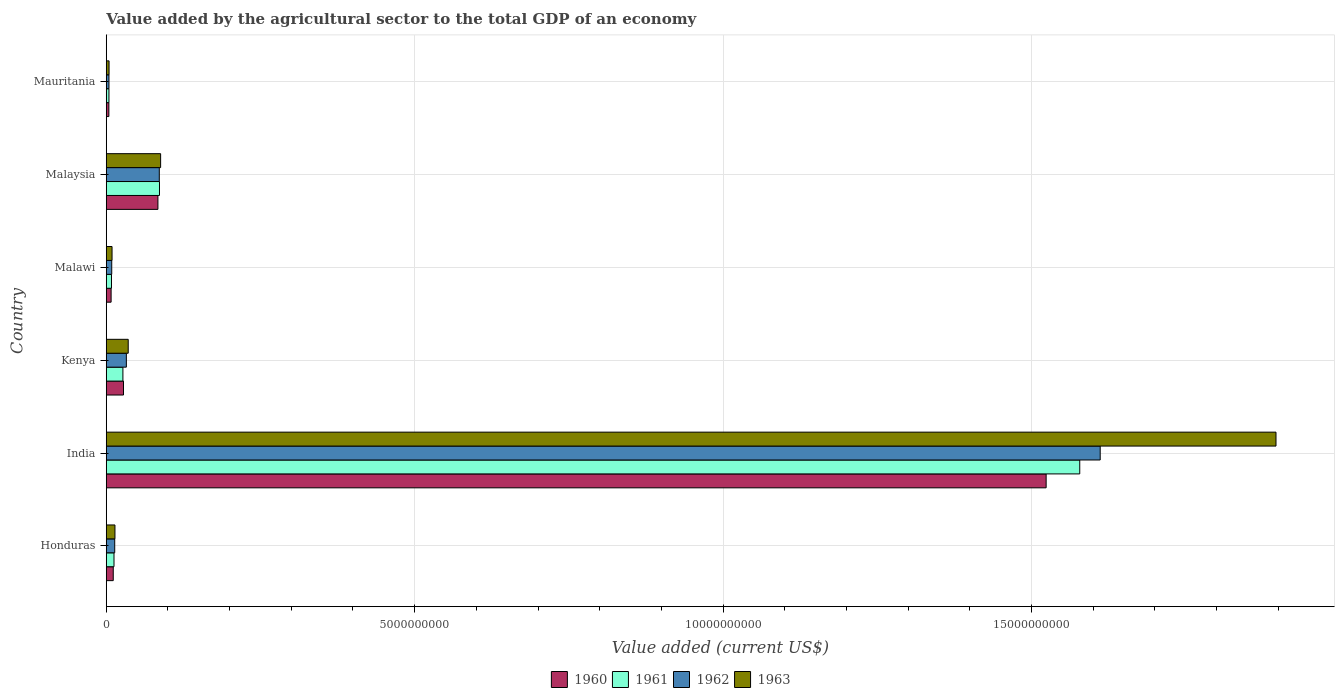How many groups of bars are there?
Your response must be concise. 6. How many bars are there on the 1st tick from the bottom?
Your response must be concise. 4. What is the label of the 5th group of bars from the top?
Your answer should be compact. India. In how many cases, is the number of bars for a given country not equal to the number of legend labels?
Your answer should be compact. 0. What is the value added by the agricultural sector to the total GDP in 1961 in Malaysia?
Your answer should be compact. 8.63e+08. Across all countries, what is the maximum value added by the agricultural sector to the total GDP in 1963?
Keep it short and to the point. 1.90e+1. Across all countries, what is the minimum value added by the agricultural sector to the total GDP in 1963?
Keep it short and to the point. 4.57e+07. In which country was the value added by the agricultural sector to the total GDP in 1962 minimum?
Your answer should be very brief. Mauritania. What is the total value added by the agricultural sector to the total GDP in 1961 in the graph?
Offer a terse response. 1.72e+1. What is the difference between the value added by the agricultural sector to the total GDP in 1960 in India and that in Malaysia?
Your answer should be very brief. 1.44e+1. What is the difference between the value added by the agricultural sector to the total GDP in 1963 in India and the value added by the agricultural sector to the total GDP in 1961 in Malawi?
Provide a succinct answer. 1.89e+1. What is the average value added by the agricultural sector to the total GDP in 1962 per country?
Keep it short and to the point. 2.93e+09. What is the difference between the value added by the agricultural sector to the total GDP in 1962 and value added by the agricultural sector to the total GDP in 1961 in Malawi?
Your answer should be compact. 4.20e+06. In how many countries, is the value added by the agricultural sector to the total GDP in 1960 greater than 2000000000 US$?
Offer a terse response. 1. What is the ratio of the value added by the agricultural sector to the total GDP in 1961 in Honduras to that in India?
Offer a very short reply. 0.01. Is the difference between the value added by the agricultural sector to the total GDP in 1962 in Malaysia and Mauritania greater than the difference between the value added by the agricultural sector to the total GDP in 1961 in Malaysia and Mauritania?
Offer a very short reply. No. What is the difference between the highest and the second highest value added by the agricultural sector to the total GDP in 1961?
Your answer should be compact. 1.49e+1. What is the difference between the highest and the lowest value added by the agricultural sector to the total GDP in 1962?
Provide a short and direct response. 1.61e+1. Is it the case that in every country, the sum of the value added by the agricultural sector to the total GDP in 1962 and value added by the agricultural sector to the total GDP in 1960 is greater than the sum of value added by the agricultural sector to the total GDP in 1961 and value added by the agricultural sector to the total GDP in 1963?
Offer a terse response. No. What does the 2nd bar from the top in Honduras represents?
Offer a terse response. 1962. How many bars are there?
Provide a short and direct response. 24. What is the difference between two consecutive major ticks on the X-axis?
Give a very brief answer. 5.00e+09. Are the values on the major ticks of X-axis written in scientific E-notation?
Provide a succinct answer. No. Does the graph contain any zero values?
Offer a very short reply. No. How many legend labels are there?
Ensure brevity in your answer.  4. What is the title of the graph?
Give a very brief answer. Value added by the agricultural sector to the total GDP of an economy. Does "2006" appear as one of the legend labels in the graph?
Offer a very short reply. No. What is the label or title of the X-axis?
Offer a very short reply. Value added (current US$). What is the Value added (current US$) in 1960 in Honduras?
Offer a very short reply. 1.14e+08. What is the Value added (current US$) of 1961 in Honduras?
Ensure brevity in your answer.  1.26e+08. What is the Value added (current US$) in 1962 in Honduras?
Your answer should be very brief. 1.37e+08. What is the Value added (current US$) in 1963 in Honduras?
Offer a terse response. 1.41e+08. What is the Value added (current US$) of 1960 in India?
Give a very brief answer. 1.52e+1. What is the Value added (current US$) of 1961 in India?
Offer a very short reply. 1.58e+1. What is the Value added (current US$) of 1962 in India?
Provide a short and direct response. 1.61e+1. What is the Value added (current US$) of 1963 in India?
Keep it short and to the point. 1.90e+1. What is the Value added (current US$) of 1960 in Kenya?
Your answer should be very brief. 2.80e+08. What is the Value added (current US$) in 1961 in Kenya?
Ensure brevity in your answer.  2.70e+08. What is the Value added (current US$) of 1962 in Kenya?
Give a very brief answer. 3.26e+08. What is the Value added (current US$) in 1963 in Kenya?
Ensure brevity in your answer.  3.56e+08. What is the Value added (current US$) in 1960 in Malawi?
Provide a short and direct response. 7.88e+07. What is the Value added (current US$) of 1961 in Malawi?
Your answer should be very brief. 8.48e+07. What is the Value added (current US$) in 1962 in Malawi?
Make the answer very short. 8.90e+07. What is the Value added (current US$) in 1963 in Malawi?
Your answer should be very brief. 9.39e+07. What is the Value added (current US$) in 1960 in Malaysia?
Offer a terse response. 8.38e+08. What is the Value added (current US$) in 1961 in Malaysia?
Ensure brevity in your answer.  8.63e+08. What is the Value added (current US$) in 1962 in Malaysia?
Make the answer very short. 8.60e+08. What is the Value added (current US$) of 1963 in Malaysia?
Ensure brevity in your answer.  8.82e+08. What is the Value added (current US$) in 1960 in Mauritania?
Give a very brief answer. 4.26e+07. What is the Value added (current US$) in 1961 in Mauritania?
Your answer should be compact. 4.37e+07. What is the Value added (current US$) in 1962 in Mauritania?
Provide a short and direct response. 4.41e+07. What is the Value added (current US$) of 1963 in Mauritania?
Your response must be concise. 4.57e+07. Across all countries, what is the maximum Value added (current US$) in 1960?
Give a very brief answer. 1.52e+1. Across all countries, what is the maximum Value added (current US$) of 1961?
Offer a very short reply. 1.58e+1. Across all countries, what is the maximum Value added (current US$) in 1962?
Your answer should be very brief. 1.61e+1. Across all countries, what is the maximum Value added (current US$) of 1963?
Provide a short and direct response. 1.90e+1. Across all countries, what is the minimum Value added (current US$) of 1960?
Give a very brief answer. 4.26e+07. Across all countries, what is the minimum Value added (current US$) in 1961?
Give a very brief answer. 4.37e+07. Across all countries, what is the minimum Value added (current US$) of 1962?
Ensure brevity in your answer.  4.41e+07. Across all countries, what is the minimum Value added (current US$) in 1963?
Offer a very short reply. 4.57e+07. What is the total Value added (current US$) of 1960 in the graph?
Give a very brief answer. 1.66e+1. What is the total Value added (current US$) of 1961 in the graph?
Ensure brevity in your answer.  1.72e+1. What is the total Value added (current US$) of 1962 in the graph?
Offer a very short reply. 1.76e+1. What is the total Value added (current US$) in 1963 in the graph?
Provide a succinct answer. 2.05e+1. What is the difference between the Value added (current US$) in 1960 in Honduras and that in India?
Give a very brief answer. -1.51e+1. What is the difference between the Value added (current US$) of 1961 in Honduras and that in India?
Ensure brevity in your answer.  -1.57e+1. What is the difference between the Value added (current US$) of 1962 in Honduras and that in India?
Your answer should be compact. -1.60e+1. What is the difference between the Value added (current US$) in 1963 in Honduras and that in India?
Ensure brevity in your answer.  -1.88e+1. What is the difference between the Value added (current US$) of 1960 in Honduras and that in Kenya?
Your response must be concise. -1.66e+08. What is the difference between the Value added (current US$) in 1961 in Honduras and that in Kenya?
Offer a terse response. -1.45e+08. What is the difference between the Value added (current US$) in 1962 in Honduras and that in Kenya?
Your response must be concise. -1.89e+08. What is the difference between the Value added (current US$) of 1963 in Honduras and that in Kenya?
Your answer should be very brief. -2.15e+08. What is the difference between the Value added (current US$) in 1960 in Honduras and that in Malawi?
Keep it short and to the point. 3.47e+07. What is the difference between the Value added (current US$) of 1961 in Honduras and that in Malawi?
Make the answer very short. 4.08e+07. What is the difference between the Value added (current US$) in 1962 in Honduras and that in Malawi?
Ensure brevity in your answer.  4.82e+07. What is the difference between the Value added (current US$) of 1963 in Honduras and that in Malawi?
Your answer should be compact. 4.72e+07. What is the difference between the Value added (current US$) of 1960 in Honduras and that in Malaysia?
Give a very brief answer. -7.24e+08. What is the difference between the Value added (current US$) in 1961 in Honduras and that in Malaysia?
Offer a very short reply. -7.37e+08. What is the difference between the Value added (current US$) of 1962 in Honduras and that in Malaysia?
Give a very brief answer. -7.23e+08. What is the difference between the Value added (current US$) of 1963 in Honduras and that in Malaysia?
Your response must be concise. -7.40e+08. What is the difference between the Value added (current US$) of 1960 in Honduras and that in Mauritania?
Your answer should be very brief. 7.09e+07. What is the difference between the Value added (current US$) of 1961 in Honduras and that in Mauritania?
Your response must be concise. 8.19e+07. What is the difference between the Value added (current US$) of 1962 in Honduras and that in Mauritania?
Ensure brevity in your answer.  9.31e+07. What is the difference between the Value added (current US$) in 1963 in Honduras and that in Mauritania?
Offer a terse response. 9.55e+07. What is the difference between the Value added (current US$) of 1960 in India and that in Kenya?
Provide a short and direct response. 1.50e+1. What is the difference between the Value added (current US$) of 1961 in India and that in Kenya?
Your answer should be compact. 1.55e+1. What is the difference between the Value added (current US$) in 1962 in India and that in Kenya?
Provide a succinct answer. 1.58e+1. What is the difference between the Value added (current US$) in 1963 in India and that in Kenya?
Provide a short and direct response. 1.86e+1. What is the difference between the Value added (current US$) in 1960 in India and that in Malawi?
Provide a succinct answer. 1.52e+1. What is the difference between the Value added (current US$) of 1961 in India and that in Malawi?
Offer a terse response. 1.57e+1. What is the difference between the Value added (current US$) in 1962 in India and that in Malawi?
Offer a very short reply. 1.60e+1. What is the difference between the Value added (current US$) of 1963 in India and that in Malawi?
Your answer should be very brief. 1.89e+1. What is the difference between the Value added (current US$) in 1960 in India and that in Malaysia?
Ensure brevity in your answer.  1.44e+1. What is the difference between the Value added (current US$) in 1961 in India and that in Malaysia?
Keep it short and to the point. 1.49e+1. What is the difference between the Value added (current US$) in 1962 in India and that in Malaysia?
Your response must be concise. 1.53e+1. What is the difference between the Value added (current US$) of 1963 in India and that in Malaysia?
Your response must be concise. 1.81e+1. What is the difference between the Value added (current US$) of 1960 in India and that in Mauritania?
Your answer should be compact. 1.52e+1. What is the difference between the Value added (current US$) of 1961 in India and that in Mauritania?
Offer a very short reply. 1.57e+1. What is the difference between the Value added (current US$) in 1962 in India and that in Mauritania?
Provide a succinct answer. 1.61e+1. What is the difference between the Value added (current US$) of 1963 in India and that in Mauritania?
Keep it short and to the point. 1.89e+1. What is the difference between the Value added (current US$) in 1960 in Kenya and that in Malawi?
Your answer should be very brief. 2.01e+08. What is the difference between the Value added (current US$) of 1961 in Kenya and that in Malawi?
Your answer should be compact. 1.85e+08. What is the difference between the Value added (current US$) in 1962 in Kenya and that in Malawi?
Keep it short and to the point. 2.37e+08. What is the difference between the Value added (current US$) of 1963 in Kenya and that in Malawi?
Your response must be concise. 2.62e+08. What is the difference between the Value added (current US$) of 1960 in Kenya and that in Malaysia?
Your answer should be compact. -5.58e+08. What is the difference between the Value added (current US$) of 1961 in Kenya and that in Malaysia?
Give a very brief answer. -5.93e+08. What is the difference between the Value added (current US$) of 1962 in Kenya and that in Malaysia?
Give a very brief answer. -5.34e+08. What is the difference between the Value added (current US$) in 1963 in Kenya and that in Malaysia?
Ensure brevity in your answer.  -5.25e+08. What is the difference between the Value added (current US$) of 1960 in Kenya and that in Mauritania?
Offer a very short reply. 2.37e+08. What is the difference between the Value added (current US$) in 1961 in Kenya and that in Mauritania?
Your answer should be very brief. 2.26e+08. What is the difference between the Value added (current US$) of 1962 in Kenya and that in Mauritania?
Offer a very short reply. 2.82e+08. What is the difference between the Value added (current US$) in 1963 in Kenya and that in Mauritania?
Give a very brief answer. 3.11e+08. What is the difference between the Value added (current US$) of 1960 in Malawi and that in Malaysia?
Provide a succinct answer. -7.59e+08. What is the difference between the Value added (current US$) of 1961 in Malawi and that in Malaysia?
Offer a terse response. -7.78e+08. What is the difference between the Value added (current US$) of 1962 in Malawi and that in Malaysia?
Provide a succinct answer. -7.71e+08. What is the difference between the Value added (current US$) of 1963 in Malawi and that in Malaysia?
Ensure brevity in your answer.  -7.88e+08. What is the difference between the Value added (current US$) in 1960 in Malawi and that in Mauritania?
Keep it short and to the point. 3.62e+07. What is the difference between the Value added (current US$) of 1961 in Malawi and that in Mauritania?
Offer a terse response. 4.11e+07. What is the difference between the Value added (current US$) in 1962 in Malawi and that in Mauritania?
Give a very brief answer. 4.49e+07. What is the difference between the Value added (current US$) of 1963 in Malawi and that in Mauritania?
Provide a short and direct response. 4.83e+07. What is the difference between the Value added (current US$) in 1960 in Malaysia and that in Mauritania?
Provide a succinct answer. 7.95e+08. What is the difference between the Value added (current US$) in 1961 in Malaysia and that in Mauritania?
Offer a terse response. 8.19e+08. What is the difference between the Value added (current US$) of 1962 in Malaysia and that in Mauritania?
Keep it short and to the point. 8.16e+08. What is the difference between the Value added (current US$) in 1963 in Malaysia and that in Mauritania?
Your response must be concise. 8.36e+08. What is the difference between the Value added (current US$) in 1960 in Honduras and the Value added (current US$) in 1961 in India?
Your response must be concise. -1.57e+1. What is the difference between the Value added (current US$) of 1960 in Honduras and the Value added (current US$) of 1962 in India?
Ensure brevity in your answer.  -1.60e+1. What is the difference between the Value added (current US$) in 1960 in Honduras and the Value added (current US$) in 1963 in India?
Make the answer very short. -1.89e+1. What is the difference between the Value added (current US$) in 1961 in Honduras and the Value added (current US$) in 1962 in India?
Your answer should be very brief. -1.60e+1. What is the difference between the Value added (current US$) in 1961 in Honduras and the Value added (current US$) in 1963 in India?
Offer a terse response. -1.88e+1. What is the difference between the Value added (current US$) of 1962 in Honduras and the Value added (current US$) of 1963 in India?
Keep it short and to the point. -1.88e+1. What is the difference between the Value added (current US$) in 1960 in Honduras and the Value added (current US$) in 1961 in Kenya?
Offer a very short reply. -1.57e+08. What is the difference between the Value added (current US$) of 1960 in Honduras and the Value added (current US$) of 1962 in Kenya?
Provide a short and direct response. -2.13e+08. What is the difference between the Value added (current US$) of 1960 in Honduras and the Value added (current US$) of 1963 in Kenya?
Give a very brief answer. -2.43e+08. What is the difference between the Value added (current US$) in 1961 in Honduras and the Value added (current US$) in 1962 in Kenya?
Your response must be concise. -2.01e+08. What is the difference between the Value added (current US$) in 1961 in Honduras and the Value added (current US$) in 1963 in Kenya?
Provide a succinct answer. -2.31e+08. What is the difference between the Value added (current US$) of 1962 in Honduras and the Value added (current US$) of 1963 in Kenya?
Give a very brief answer. -2.19e+08. What is the difference between the Value added (current US$) in 1960 in Honduras and the Value added (current US$) in 1961 in Malawi?
Offer a very short reply. 2.87e+07. What is the difference between the Value added (current US$) of 1960 in Honduras and the Value added (current US$) of 1962 in Malawi?
Keep it short and to the point. 2.45e+07. What is the difference between the Value added (current US$) of 1960 in Honduras and the Value added (current US$) of 1963 in Malawi?
Provide a succinct answer. 1.96e+07. What is the difference between the Value added (current US$) in 1961 in Honduras and the Value added (current US$) in 1962 in Malawi?
Your answer should be compact. 3.66e+07. What is the difference between the Value added (current US$) in 1961 in Honduras and the Value added (current US$) in 1963 in Malawi?
Offer a terse response. 3.17e+07. What is the difference between the Value added (current US$) of 1962 in Honduras and the Value added (current US$) of 1963 in Malawi?
Offer a very short reply. 4.33e+07. What is the difference between the Value added (current US$) in 1960 in Honduras and the Value added (current US$) in 1961 in Malaysia?
Keep it short and to the point. -7.50e+08. What is the difference between the Value added (current US$) in 1960 in Honduras and the Value added (current US$) in 1962 in Malaysia?
Ensure brevity in your answer.  -7.47e+08. What is the difference between the Value added (current US$) in 1960 in Honduras and the Value added (current US$) in 1963 in Malaysia?
Keep it short and to the point. -7.68e+08. What is the difference between the Value added (current US$) of 1961 in Honduras and the Value added (current US$) of 1962 in Malaysia?
Ensure brevity in your answer.  -7.34e+08. What is the difference between the Value added (current US$) of 1961 in Honduras and the Value added (current US$) of 1963 in Malaysia?
Provide a short and direct response. -7.56e+08. What is the difference between the Value added (current US$) in 1962 in Honduras and the Value added (current US$) in 1963 in Malaysia?
Ensure brevity in your answer.  -7.44e+08. What is the difference between the Value added (current US$) in 1960 in Honduras and the Value added (current US$) in 1961 in Mauritania?
Provide a succinct answer. 6.98e+07. What is the difference between the Value added (current US$) of 1960 in Honduras and the Value added (current US$) of 1962 in Mauritania?
Your answer should be very brief. 6.94e+07. What is the difference between the Value added (current US$) in 1960 in Honduras and the Value added (current US$) in 1963 in Mauritania?
Offer a very short reply. 6.78e+07. What is the difference between the Value added (current US$) of 1961 in Honduras and the Value added (current US$) of 1962 in Mauritania?
Offer a very short reply. 8.15e+07. What is the difference between the Value added (current US$) in 1961 in Honduras and the Value added (current US$) in 1963 in Mauritania?
Offer a terse response. 7.99e+07. What is the difference between the Value added (current US$) in 1962 in Honduras and the Value added (current US$) in 1963 in Mauritania?
Offer a terse response. 9.16e+07. What is the difference between the Value added (current US$) of 1960 in India and the Value added (current US$) of 1961 in Kenya?
Your response must be concise. 1.50e+1. What is the difference between the Value added (current US$) in 1960 in India and the Value added (current US$) in 1962 in Kenya?
Make the answer very short. 1.49e+1. What is the difference between the Value added (current US$) in 1960 in India and the Value added (current US$) in 1963 in Kenya?
Make the answer very short. 1.49e+1. What is the difference between the Value added (current US$) of 1961 in India and the Value added (current US$) of 1962 in Kenya?
Offer a very short reply. 1.55e+1. What is the difference between the Value added (current US$) of 1961 in India and the Value added (current US$) of 1963 in Kenya?
Your response must be concise. 1.54e+1. What is the difference between the Value added (current US$) of 1962 in India and the Value added (current US$) of 1963 in Kenya?
Make the answer very short. 1.58e+1. What is the difference between the Value added (current US$) of 1960 in India and the Value added (current US$) of 1961 in Malawi?
Offer a very short reply. 1.52e+1. What is the difference between the Value added (current US$) of 1960 in India and the Value added (current US$) of 1962 in Malawi?
Ensure brevity in your answer.  1.51e+1. What is the difference between the Value added (current US$) in 1960 in India and the Value added (current US$) in 1963 in Malawi?
Keep it short and to the point. 1.51e+1. What is the difference between the Value added (current US$) in 1961 in India and the Value added (current US$) in 1962 in Malawi?
Make the answer very short. 1.57e+1. What is the difference between the Value added (current US$) in 1961 in India and the Value added (current US$) in 1963 in Malawi?
Ensure brevity in your answer.  1.57e+1. What is the difference between the Value added (current US$) in 1962 in India and the Value added (current US$) in 1963 in Malawi?
Provide a short and direct response. 1.60e+1. What is the difference between the Value added (current US$) in 1960 in India and the Value added (current US$) in 1961 in Malaysia?
Offer a terse response. 1.44e+1. What is the difference between the Value added (current US$) in 1960 in India and the Value added (current US$) in 1962 in Malaysia?
Offer a terse response. 1.44e+1. What is the difference between the Value added (current US$) of 1960 in India and the Value added (current US$) of 1963 in Malaysia?
Keep it short and to the point. 1.44e+1. What is the difference between the Value added (current US$) in 1961 in India and the Value added (current US$) in 1962 in Malaysia?
Offer a terse response. 1.49e+1. What is the difference between the Value added (current US$) in 1961 in India and the Value added (current US$) in 1963 in Malaysia?
Give a very brief answer. 1.49e+1. What is the difference between the Value added (current US$) of 1962 in India and the Value added (current US$) of 1963 in Malaysia?
Offer a terse response. 1.52e+1. What is the difference between the Value added (current US$) of 1960 in India and the Value added (current US$) of 1961 in Mauritania?
Keep it short and to the point. 1.52e+1. What is the difference between the Value added (current US$) in 1960 in India and the Value added (current US$) in 1962 in Mauritania?
Your answer should be very brief. 1.52e+1. What is the difference between the Value added (current US$) in 1960 in India and the Value added (current US$) in 1963 in Mauritania?
Your answer should be compact. 1.52e+1. What is the difference between the Value added (current US$) of 1961 in India and the Value added (current US$) of 1962 in Mauritania?
Ensure brevity in your answer.  1.57e+1. What is the difference between the Value added (current US$) of 1961 in India and the Value added (current US$) of 1963 in Mauritania?
Ensure brevity in your answer.  1.57e+1. What is the difference between the Value added (current US$) of 1962 in India and the Value added (current US$) of 1963 in Mauritania?
Make the answer very short. 1.61e+1. What is the difference between the Value added (current US$) of 1960 in Kenya and the Value added (current US$) of 1961 in Malawi?
Ensure brevity in your answer.  1.95e+08. What is the difference between the Value added (current US$) of 1960 in Kenya and the Value added (current US$) of 1962 in Malawi?
Provide a succinct answer. 1.91e+08. What is the difference between the Value added (current US$) of 1960 in Kenya and the Value added (current US$) of 1963 in Malawi?
Offer a terse response. 1.86e+08. What is the difference between the Value added (current US$) in 1961 in Kenya and the Value added (current US$) in 1962 in Malawi?
Your answer should be compact. 1.81e+08. What is the difference between the Value added (current US$) in 1961 in Kenya and the Value added (current US$) in 1963 in Malawi?
Ensure brevity in your answer.  1.76e+08. What is the difference between the Value added (current US$) of 1962 in Kenya and the Value added (current US$) of 1963 in Malawi?
Your response must be concise. 2.32e+08. What is the difference between the Value added (current US$) in 1960 in Kenya and the Value added (current US$) in 1961 in Malaysia?
Offer a very short reply. -5.83e+08. What is the difference between the Value added (current US$) of 1960 in Kenya and the Value added (current US$) of 1962 in Malaysia?
Offer a terse response. -5.80e+08. What is the difference between the Value added (current US$) in 1960 in Kenya and the Value added (current US$) in 1963 in Malaysia?
Provide a succinct answer. -6.02e+08. What is the difference between the Value added (current US$) in 1961 in Kenya and the Value added (current US$) in 1962 in Malaysia?
Ensure brevity in your answer.  -5.90e+08. What is the difference between the Value added (current US$) of 1961 in Kenya and the Value added (current US$) of 1963 in Malaysia?
Offer a very short reply. -6.11e+08. What is the difference between the Value added (current US$) of 1962 in Kenya and the Value added (current US$) of 1963 in Malaysia?
Offer a terse response. -5.55e+08. What is the difference between the Value added (current US$) in 1960 in Kenya and the Value added (current US$) in 1961 in Mauritania?
Provide a short and direct response. 2.36e+08. What is the difference between the Value added (current US$) of 1960 in Kenya and the Value added (current US$) of 1962 in Mauritania?
Keep it short and to the point. 2.36e+08. What is the difference between the Value added (current US$) of 1960 in Kenya and the Value added (current US$) of 1963 in Mauritania?
Your answer should be compact. 2.34e+08. What is the difference between the Value added (current US$) of 1961 in Kenya and the Value added (current US$) of 1962 in Mauritania?
Offer a terse response. 2.26e+08. What is the difference between the Value added (current US$) of 1961 in Kenya and the Value added (current US$) of 1963 in Mauritania?
Your answer should be compact. 2.25e+08. What is the difference between the Value added (current US$) in 1962 in Kenya and the Value added (current US$) in 1963 in Mauritania?
Provide a short and direct response. 2.81e+08. What is the difference between the Value added (current US$) of 1960 in Malawi and the Value added (current US$) of 1961 in Malaysia?
Offer a very short reply. -7.84e+08. What is the difference between the Value added (current US$) in 1960 in Malawi and the Value added (current US$) in 1962 in Malaysia?
Offer a terse response. -7.81e+08. What is the difference between the Value added (current US$) of 1960 in Malawi and the Value added (current US$) of 1963 in Malaysia?
Ensure brevity in your answer.  -8.03e+08. What is the difference between the Value added (current US$) of 1961 in Malawi and the Value added (current US$) of 1962 in Malaysia?
Offer a terse response. -7.75e+08. What is the difference between the Value added (current US$) of 1961 in Malawi and the Value added (current US$) of 1963 in Malaysia?
Make the answer very short. -7.97e+08. What is the difference between the Value added (current US$) in 1962 in Malawi and the Value added (current US$) in 1963 in Malaysia?
Your response must be concise. -7.93e+08. What is the difference between the Value added (current US$) in 1960 in Malawi and the Value added (current US$) in 1961 in Mauritania?
Offer a very short reply. 3.51e+07. What is the difference between the Value added (current US$) of 1960 in Malawi and the Value added (current US$) of 1962 in Mauritania?
Keep it short and to the point. 3.47e+07. What is the difference between the Value added (current US$) of 1960 in Malawi and the Value added (current US$) of 1963 in Mauritania?
Keep it short and to the point. 3.32e+07. What is the difference between the Value added (current US$) in 1961 in Malawi and the Value added (current US$) in 1962 in Mauritania?
Provide a short and direct response. 4.07e+07. What is the difference between the Value added (current US$) of 1961 in Malawi and the Value added (current US$) of 1963 in Mauritania?
Your answer should be compact. 3.92e+07. What is the difference between the Value added (current US$) of 1962 in Malawi and the Value added (current US$) of 1963 in Mauritania?
Offer a very short reply. 4.34e+07. What is the difference between the Value added (current US$) in 1960 in Malaysia and the Value added (current US$) in 1961 in Mauritania?
Give a very brief answer. 7.94e+08. What is the difference between the Value added (current US$) in 1960 in Malaysia and the Value added (current US$) in 1962 in Mauritania?
Your answer should be very brief. 7.94e+08. What is the difference between the Value added (current US$) of 1960 in Malaysia and the Value added (current US$) of 1963 in Mauritania?
Offer a very short reply. 7.92e+08. What is the difference between the Value added (current US$) in 1961 in Malaysia and the Value added (current US$) in 1962 in Mauritania?
Your response must be concise. 8.19e+08. What is the difference between the Value added (current US$) in 1961 in Malaysia and the Value added (current US$) in 1963 in Mauritania?
Keep it short and to the point. 8.17e+08. What is the difference between the Value added (current US$) of 1962 in Malaysia and the Value added (current US$) of 1963 in Mauritania?
Give a very brief answer. 8.14e+08. What is the average Value added (current US$) in 1960 per country?
Offer a very short reply. 2.77e+09. What is the average Value added (current US$) in 1961 per country?
Offer a terse response. 2.86e+09. What is the average Value added (current US$) of 1962 per country?
Make the answer very short. 2.93e+09. What is the average Value added (current US$) of 1963 per country?
Ensure brevity in your answer.  3.41e+09. What is the difference between the Value added (current US$) of 1960 and Value added (current US$) of 1961 in Honduras?
Provide a succinct answer. -1.21e+07. What is the difference between the Value added (current US$) in 1960 and Value added (current US$) in 1962 in Honduras?
Make the answer very short. -2.38e+07. What is the difference between the Value added (current US$) in 1960 and Value added (current US$) in 1963 in Honduras?
Offer a terse response. -2.76e+07. What is the difference between the Value added (current US$) of 1961 and Value added (current US$) of 1962 in Honduras?
Ensure brevity in your answer.  -1.16e+07. What is the difference between the Value added (current US$) of 1961 and Value added (current US$) of 1963 in Honduras?
Ensure brevity in your answer.  -1.56e+07. What is the difference between the Value added (current US$) in 1962 and Value added (current US$) in 1963 in Honduras?
Provide a succinct answer. -3.90e+06. What is the difference between the Value added (current US$) in 1960 and Value added (current US$) in 1961 in India?
Offer a very short reply. -5.45e+08. What is the difference between the Value added (current US$) of 1960 and Value added (current US$) of 1962 in India?
Your response must be concise. -8.76e+08. What is the difference between the Value added (current US$) of 1960 and Value added (current US$) of 1963 in India?
Ensure brevity in your answer.  -3.73e+09. What is the difference between the Value added (current US$) in 1961 and Value added (current US$) in 1962 in India?
Make the answer very short. -3.32e+08. What is the difference between the Value added (current US$) of 1961 and Value added (current US$) of 1963 in India?
Offer a very short reply. -3.18e+09. What is the difference between the Value added (current US$) of 1962 and Value added (current US$) of 1963 in India?
Keep it short and to the point. -2.85e+09. What is the difference between the Value added (current US$) in 1960 and Value added (current US$) in 1961 in Kenya?
Provide a succinct answer. 9.51e+06. What is the difference between the Value added (current US$) in 1960 and Value added (current US$) in 1962 in Kenya?
Offer a very short reply. -4.65e+07. What is the difference between the Value added (current US$) in 1960 and Value added (current US$) in 1963 in Kenya?
Keep it short and to the point. -7.66e+07. What is the difference between the Value added (current US$) of 1961 and Value added (current US$) of 1962 in Kenya?
Give a very brief answer. -5.60e+07. What is the difference between the Value added (current US$) in 1961 and Value added (current US$) in 1963 in Kenya?
Make the answer very short. -8.61e+07. What is the difference between the Value added (current US$) in 1962 and Value added (current US$) in 1963 in Kenya?
Ensure brevity in your answer.  -3.01e+07. What is the difference between the Value added (current US$) of 1960 and Value added (current US$) of 1961 in Malawi?
Your answer should be compact. -6.02e+06. What is the difference between the Value added (current US$) of 1960 and Value added (current US$) of 1962 in Malawi?
Ensure brevity in your answer.  -1.02e+07. What is the difference between the Value added (current US$) of 1960 and Value added (current US$) of 1963 in Malawi?
Make the answer very short. -1.51e+07. What is the difference between the Value added (current US$) of 1961 and Value added (current US$) of 1962 in Malawi?
Your response must be concise. -4.20e+06. What is the difference between the Value added (current US$) in 1961 and Value added (current US$) in 1963 in Malawi?
Provide a short and direct response. -9.10e+06. What is the difference between the Value added (current US$) of 1962 and Value added (current US$) of 1963 in Malawi?
Offer a terse response. -4.90e+06. What is the difference between the Value added (current US$) of 1960 and Value added (current US$) of 1961 in Malaysia?
Your response must be concise. -2.54e+07. What is the difference between the Value added (current US$) in 1960 and Value added (current US$) in 1962 in Malaysia?
Provide a succinct answer. -2.23e+07. What is the difference between the Value added (current US$) in 1960 and Value added (current US$) in 1963 in Malaysia?
Your response must be concise. -4.39e+07. What is the difference between the Value added (current US$) in 1961 and Value added (current US$) in 1962 in Malaysia?
Ensure brevity in your answer.  3.09e+06. What is the difference between the Value added (current US$) in 1961 and Value added (current US$) in 1963 in Malaysia?
Offer a very short reply. -1.85e+07. What is the difference between the Value added (current US$) in 1962 and Value added (current US$) in 1963 in Malaysia?
Provide a succinct answer. -2.16e+07. What is the difference between the Value added (current US$) in 1960 and Value added (current US$) in 1961 in Mauritania?
Your answer should be very brief. -1.15e+06. What is the difference between the Value added (current US$) of 1960 and Value added (current US$) of 1962 in Mauritania?
Provide a short and direct response. -1.54e+06. What is the difference between the Value added (current US$) in 1960 and Value added (current US$) in 1963 in Mauritania?
Give a very brief answer. -3.07e+06. What is the difference between the Value added (current US$) of 1961 and Value added (current US$) of 1962 in Mauritania?
Offer a very short reply. -3.84e+05. What is the difference between the Value added (current US$) in 1961 and Value added (current US$) in 1963 in Mauritania?
Ensure brevity in your answer.  -1.92e+06. What is the difference between the Value added (current US$) in 1962 and Value added (current US$) in 1963 in Mauritania?
Offer a very short reply. -1.54e+06. What is the ratio of the Value added (current US$) in 1960 in Honduras to that in India?
Offer a very short reply. 0.01. What is the ratio of the Value added (current US$) of 1961 in Honduras to that in India?
Ensure brevity in your answer.  0.01. What is the ratio of the Value added (current US$) of 1962 in Honduras to that in India?
Keep it short and to the point. 0.01. What is the ratio of the Value added (current US$) in 1963 in Honduras to that in India?
Your answer should be very brief. 0.01. What is the ratio of the Value added (current US$) in 1960 in Honduras to that in Kenya?
Keep it short and to the point. 0.41. What is the ratio of the Value added (current US$) in 1961 in Honduras to that in Kenya?
Offer a terse response. 0.46. What is the ratio of the Value added (current US$) in 1962 in Honduras to that in Kenya?
Make the answer very short. 0.42. What is the ratio of the Value added (current US$) of 1963 in Honduras to that in Kenya?
Give a very brief answer. 0.4. What is the ratio of the Value added (current US$) in 1960 in Honduras to that in Malawi?
Make the answer very short. 1.44. What is the ratio of the Value added (current US$) of 1961 in Honduras to that in Malawi?
Give a very brief answer. 1.48. What is the ratio of the Value added (current US$) of 1962 in Honduras to that in Malawi?
Your answer should be compact. 1.54. What is the ratio of the Value added (current US$) in 1963 in Honduras to that in Malawi?
Offer a terse response. 1.5. What is the ratio of the Value added (current US$) of 1960 in Honduras to that in Malaysia?
Ensure brevity in your answer.  0.14. What is the ratio of the Value added (current US$) in 1961 in Honduras to that in Malaysia?
Give a very brief answer. 0.15. What is the ratio of the Value added (current US$) of 1962 in Honduras to that in Malaysia?
Offer a very short reply. 0.16. What is the ratio of the Value added (current US$) of 1963 in Honduras to that in Malaysia?
Your answer should be compact. 0.16. What is the ratio of the Value added (current US$) in 1960 in Honduras to that in Mauritania?
Ensure brevity in your answer.  2.66. What is the ratio of the Value added (current US$) of 1961 in Honduras to that in Mauritania?
Make the answer very short. 2.87. What is the ratio of the Value added (current US$) of 1962 in Honduras to that in Mauritania?
Offer a very short reply. 3.11. What is the ratio of the Value added (current US$) in 1963 in Honduras to that in Mauritania?
Give a very brief answer. 3.09. What is the ratio of the Value added (current US$) of 1960 in India to that in Kenya?
Keep it short and to the point. 54.48. What is the ratio of the Value added (current US$) in 1961 in India to that in Kenya?
Offer a very short reply. 58.42. What is the ratio of the Value added (current US$) of 1962 in India to that in Kenya?
Give a very brief answer. 49.4. What is the ratio of the Value added (current US$) in 1963 in India to that in Kenya?
Provide a succinct answer. 53.23. What is the ratio of the Value added (current US$) of 1960 in India to that in Malawi?
Provide a short and direct response. 193.33. What is the ratio of the Value added (current US$) of 1961 in India to that in Malawi?
Make the answer very short. 186.04. What is the ratio of the Value added (current US$) of 1962 in India to that in Malawi?
Make the answer very short. 180.99. What is the ratio of the Value added (current US$) of 1963 in India to that in Malawi?
Ensure brevity in your answer.  201.89. What is the ratio of the Value added (current US$) in 1960 in India to that in Malaysia?
Provide a succinct answer. 18.19. What is the ratio of the Value added (current US$) of 1961 in India to that in Malaysia?
Your answer should be compact. 18.29. What is the ratio of the Value added (current US$) of 1962 in India to that in Malaysia?
Your answer should be compact. 18.74. What is the ratio of the Value added (current US$) of 1963 in India to that in Malaysia?
Your answer should be compact. 21.51. What is the ratio of the Value added (current US$) of 1960 in India to that in Mauritania?
Your answer should be compact. 357.73. What is the ratio of the Value added (current US$) of 1961 in India to that in Mauritania?
Your answer should be very brief. 360.77. What is the ratio of the Value added (current US$) in 1962 in India to that in Mauritania?
Offer a very short reply. 365.15. What is the ratio of the Value added (current US$) in 1963 in India to that in Mauritania?
Provide a short and direct response. 415.29. What is the ratio of the Value added (current US$) in 1960 in Kenya to that in Malawi?
Make the answer very short. 3.55. What is the ratio of the Value added (current US$) of 1961 in Kenya to that in Malawi?
Offer a terse response. 3.18. What is the ratio of the Value added (current US$) of 1962 in Kenya to that in Malawi?
Offer a very short reply. 3.66. What is the ratio of the Value added (current US$) of 1963 in Kenya to that in Malawi?
Your answer should be very brief. 3.79. What is the ratio of the Value added (current US$) in 1960 in Kenya to that in Malaysia?
Your answer should be compact. 0.33. What is the ratio of the Value added (current US$) of 1961 in Kenya to that in Malaysia?
Provide a short and direct response. 0.31. What is the ratio of the Value added (current US$) in 1962 in Kenya to that in Malaysia?
Provide a short and direct response. 0.38. What is the ratio of the Value added (current US$) in 1963 in Kenya to that in Malaysia?
Ensure brevity in your answer.  0.4. What is the ratio of the Value added (current US$) in 1960 in Kenya to that in Mauritania?
Offer a terse response. 6.57. What is the ratio of the Value added (current US$) in 1961 in Kenya to that in Mauritania?
Provide a succinct answer. 6.18. What is the ratio of the Value added (current US$) in 1962 in Kenya to that in Mauritania?
Make the answer very short. 7.39. What is the ratio of the Value added (current US$) of 1963 in Kenya to that in Mauritania?
Provide a short and direct response. 7.8. What is the ratio of the Value added (current US$) in 1960 in Malawi to that in Malaysia?
Ensure brevity in your answer.  0.09. What is the ratio of the Value added (current US$) of 1961 in Malawi to that in Malaysia?
Make the answer very short. 0.1. What is the ratio of the Value added (current US$) of 1962 in Malawi to that in Malaysia?
Ensure brevity in your answer.  0.1. What is the ratio of the Value added (current US$) in 1963 in Malawi to that in Malaysia?
Keep it short and to the point. 0.11. What is the ratio of the Value added (current US$) in 1960 in Malawi to that in Mauritania?
Offer a terse response. 1.85. What is the ratio of the Value added (current US$) of 1961 in Malawi to that in Mauritania?
Make the answer very short. 1.94. What is the ratio of the Value added (current US$) of 1962 in Malawi to that in Mauritania?
Your answer should be very brief. 2.02. What is the ratio of the Value added (current US$) of 1963 in Malawi to that in Mauritania?
Ensure brevity in your answer.  2.06. What is the ratio of the Value added (current US$) in 1960 in Malaysia to that in Mauritania?
Offer a terse response. 19.67. What is the ratio of the Value added (current US$) in 1961 in Malaysia to that in Mauritania?
Your answer should be very brief. 19.73. What is the ratio of the Value added (current US$) in 1962 in Malaysia to that in Mauritania?
Your answer should be very brief. 19.49. What is the ratio of the Value added (current US$) of 1963 in Malaysia to that in Mauritania?
Offer a very short reply. 19.31. What is the difference between the highest and the second highest Value added (current US$) in 1960?
Your response must be concise. 1.44e+1. What is the difference between the highest and the second highest Value added (current US$) in 1961?
Make the answer very short. 1.49e+1. What is the difference between the highest and the second highest Value added (current US$) in 1962?
Your response must be concise. 1.53e+1. What is the difference between the highest and the second highest Value added (current US$) in 1963?
Give a very brief answer. 1.81e+1. What is the difference between the highest and the lowest Value added (current US$) of 1960?
Keep it short and to the point. 1.52e+1. What is the difference between the highest and the lowest Value added (current US$) in 1961?
Provide a succinct answer. 1.57e+1. What is the difference between the highest and the lowest Value added (current US$) in 1962?
Offer a very short reply. 1.61e+1. What is the difference between the highest and the lowest Value added (current US$) in 1963?
Offer a very short reply. 1.89e+1. 